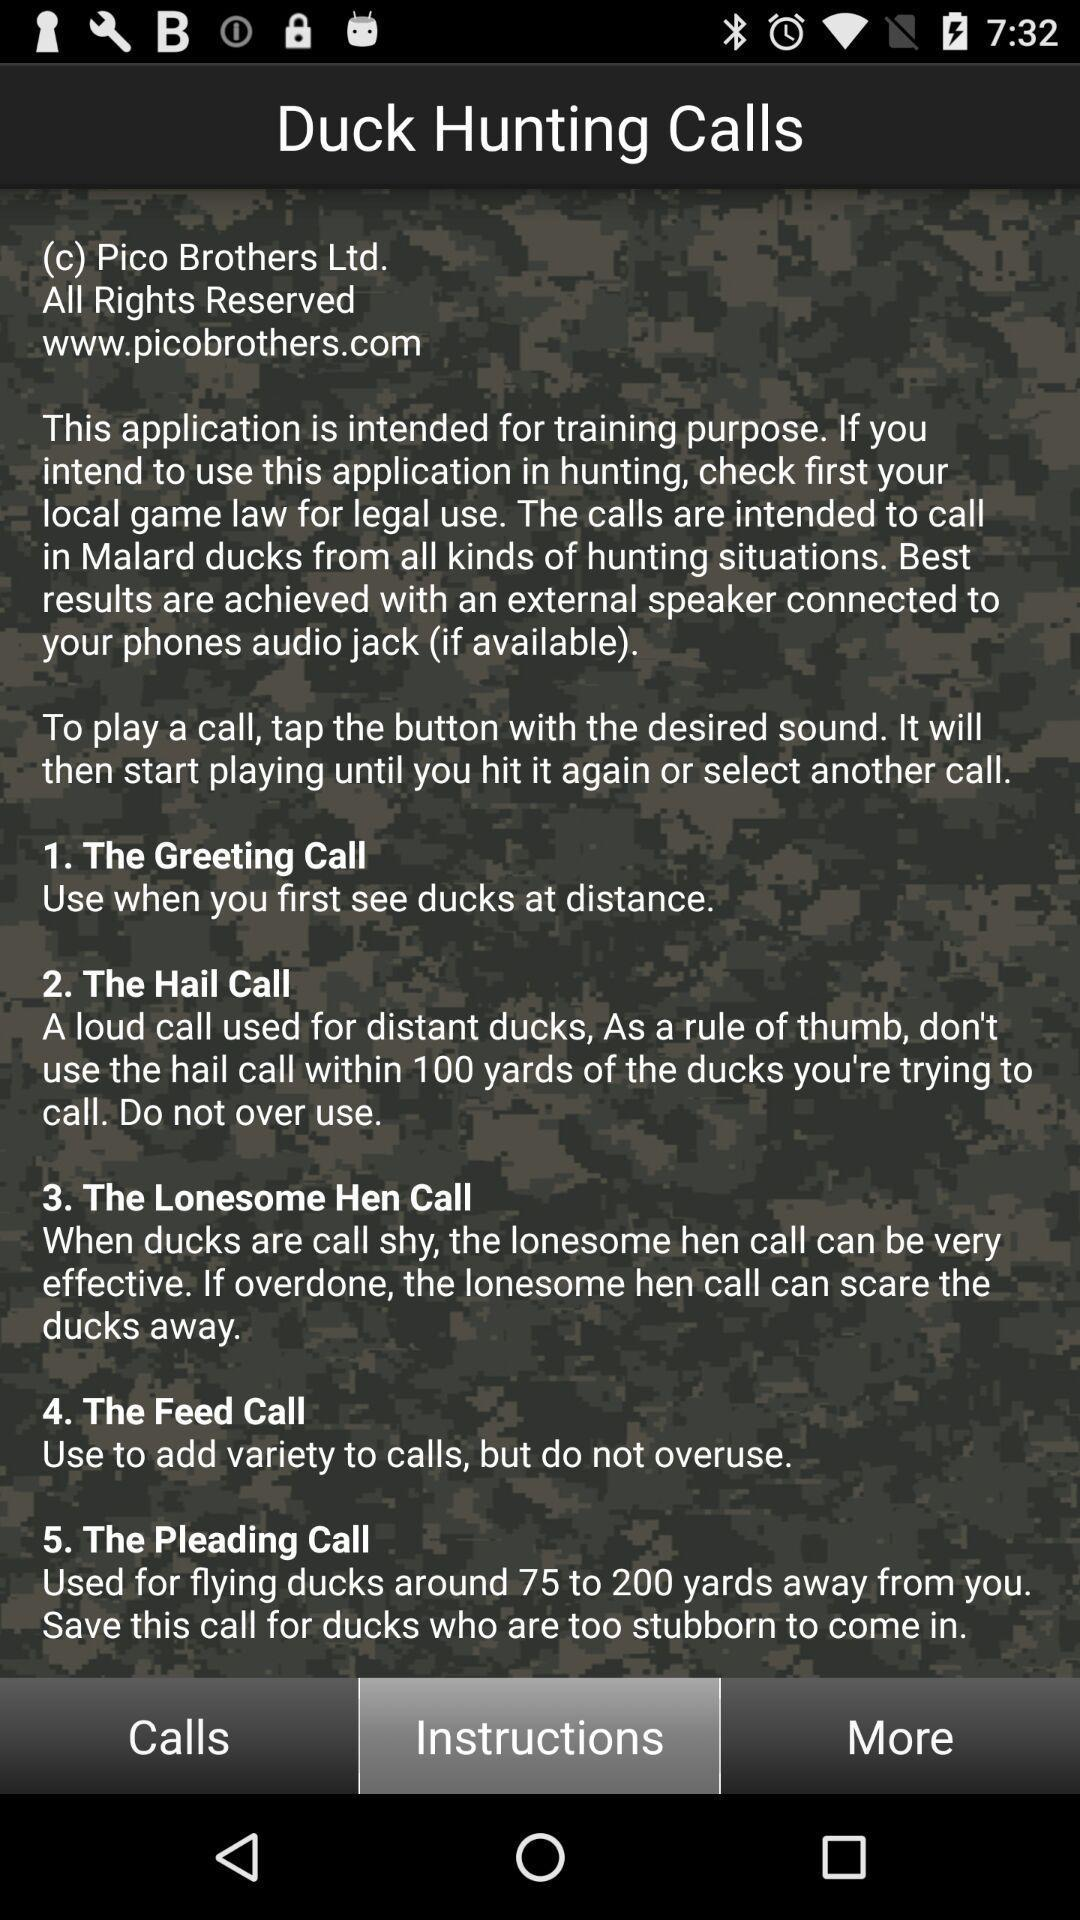Which tab is selected? The selected tab is "Instructions". 